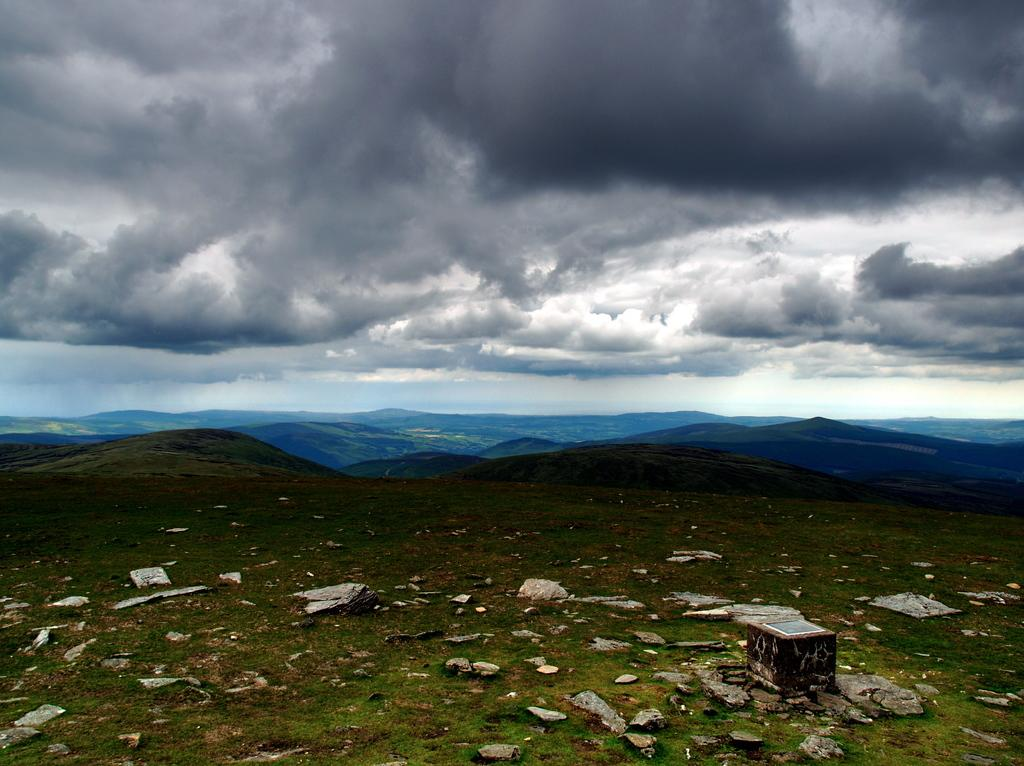What type of natural elements can be seen on the grass in the image? There are stones on the grass in the image. What is located on the right side of the image? There is an object on the right side of the image. What type of landscape can be seen in the background of the image? Mountains are visible in the background of the image. What is the weather like in the image? The sky is cloudy in the image. Can you see any police officers or flames in the image? No, there are no police officers or flames present in the image. What type of building material is visible in the image? There is no specific building material mentioned in the provided facts, so we cannot determine if there is any brick visible in the image. 